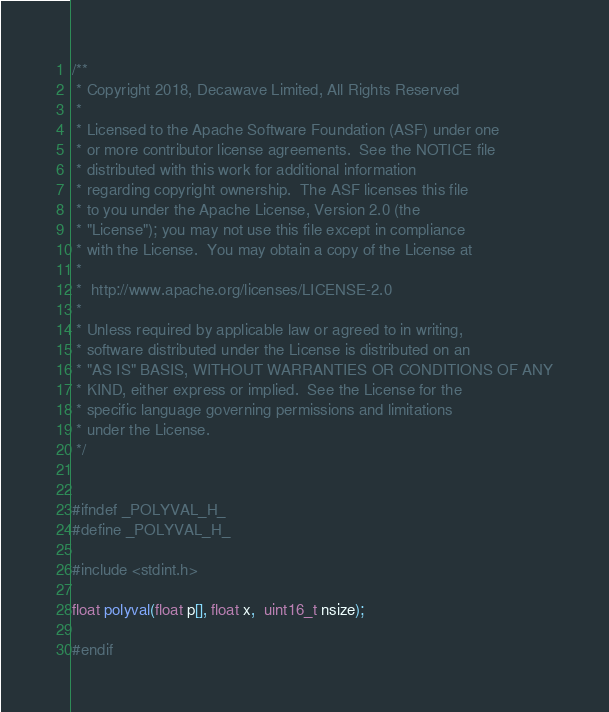Convert code to text. <code><loc_0><loc_0><loc_500><loc_500><_C_>/**
 * Copyright 2018, Decawave Limited, All Rights Reserved
 * 
 * Licensed to the Apache Software Foundation (ASF) under one
 * or more contributor license agreements.  See the NOTICE file
 * distributed with this work for additional information
 * regarding copyright ownership.  The ASF licenses this file
 * to you under the Apache License, Version 2.0 (the
 * "License"); you may not use this file except in compliance
 * with the License.  You may obtain a copy of the License at
 * 
 *  http://www.apache.org/licenses/LICENSE-2.0
 *
 * Unless required by applicable law or agreed to in writing,
 * software distributed under the License is distributed on an
 * "AS IS" BASIS, WITHOUT WARRANTIES OR CONDITIONS OF ANY
 * KIND, either express or implied.  See the License for the
 * specific language governing permissions and limitations
 * under the License.
 */


#ifndef _POLYVAL_H_
#define _POLYVAL_H_

#include <stdint.h>

float polyval(float p[], float x,  uint16_t nsize);

#endif



</code> 